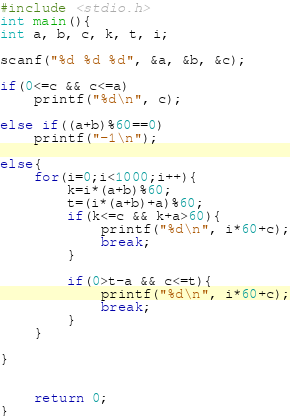Convert code to text. <code><loc_0><loc_0><loc_500><loc_500><_C_>#include <stdio.h>
int main(){
int a, b, c, k, t, i;

scanf("%d %d %d", &a, &b, &c);

if(0<=c && c<=a)
	printf("%d\n", c);

else if((a+b)%60==0)
	printf("-1\n");

else{
	for(i=0;i<1000;i++){
		k=i*(a+b)%60;
		t=(i*(a+b)+a)%60;
		if(k<=c && k+a>60){
			printf("%d\n", i*60+c);
			break;
		}
		
		if(0>t-a && c<=t){
			printf("%d\n", i*60+c);
			break;
		}
	}
	
}


	return 0;
}</code> 